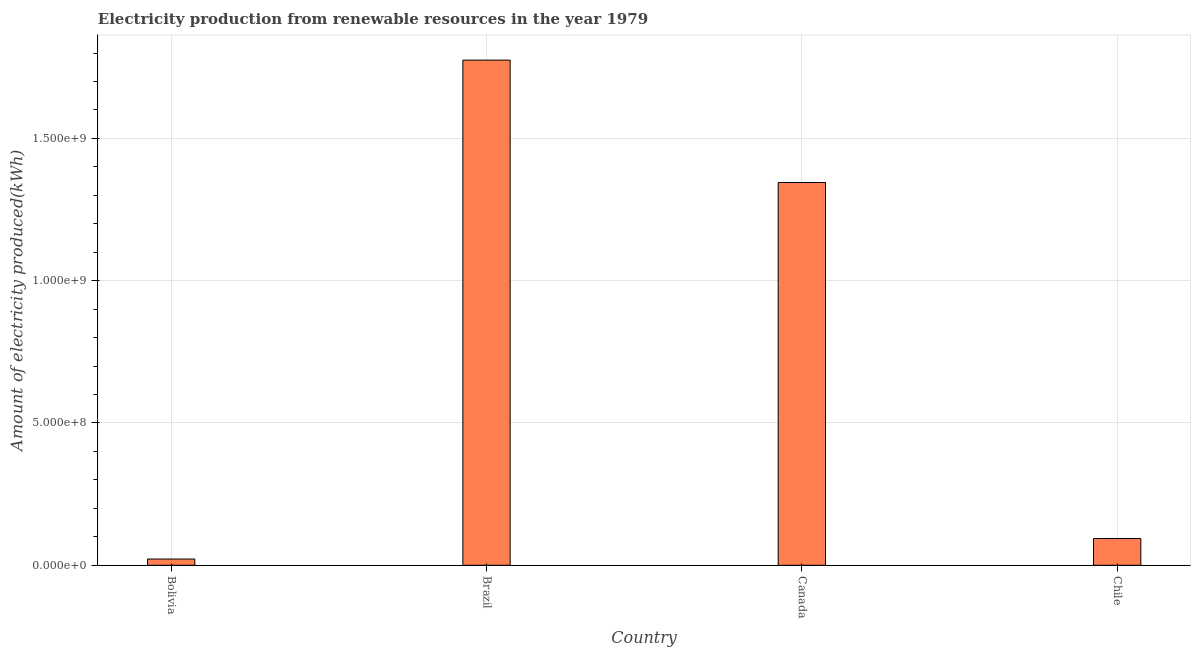What is the title of the graph?
Ensure brevity in your answer.  Electricity production from renewable resources in the year 1979. What is the label or title of the X-axis?
Offer a very short reply. Country. What is the label or title of the Y-axis?
Offer a terse response. Amount of electricity produced(kWh). What is the amount of electricity produced in Bolivia?
Offer a very short reply. 2.20e+07. Across all countries, what is the maximum amount of electricity produced?
Ensure brevity in your answer.  1.78e+09. Across all countries, what is the minimum amount of electricity produced?
Offer a terse response. 2.20e+07. In which country was the amount of electricity produced maximum?
Give a very brief answer. Brazil. What is the sum of the amount of electricity produced?
Offer a terse response. 3.24e+09. What is the difference between the amount of electricity produced in Brazil and Canada?
Provide a short and direct response. 4.30e+08. What is the average amount of electricity produced per country?
Make the answer very short. 8.09e+08. What is the median amount of electricity produced?
Give a very brief answer. 7.20e+08. In how many countries, is the amount of electricity produced greater than 1700000000 kWh?
Your answer should be compact. 1. What is the ratio of the amount of electricity produced in Bolivia to that in Chile?
Your response must be concise. 0.23. Is the difference between the amount of electricity produced in Bolivia and Canada greater than the difference between any two countries?
Provide a succinct answer. No. What is the difference between the highest and the second highest amount of electricity produced?
Your answer should be compact. 4.30e+08. Is the sum of the amount of electricity produced in Brazil and Canada greater than the maximum amount of electricity produced across all countries?
Make the answer very short. Yes. What is the difference between the highest and the lowest amount of electricity produced?
Your response must be concise. 1.75e+09. Are all the bars in the graph horizontal?
Ensure brevity in your answer.  No. What is the difference between two consecutive major ticks on the Y-axis?
Your answer should be compact. 5.00e+08. Are the values on the major ticks of Y-axis written in scientific E-notation?
Make the answer very short. Yes. What is the Amount of electricity produced(kWh) of Bolivia?
Offer a very short reply. 2.20e+07. What is the Amount of electricity produced(kWh) in Brazil?
Make the answer very short. 1.78e+09. What is the Amount of electricity produced(kWh) of Canada?
Provide a short and direct response. 1.34e+09. What is the Amount of electricity produced(kWh) in Chile?
Keep it short and to the point. 9.40e+07. What is the difference between the Amount of electricity produced(kWh) in Bolivia and Brazil?
Provide a short and direct response. -1.75e+09. What is the difference between the Amount of electricity produced(kWh) in Bolivia and Canada?
Provide a succinct answer. -1.32e+09. What is the difference between the Amount of electricity produced(kWh) in Bolivia and Chile?
Provide a succinct answer. -7.20e+07. What is the difference between the Amount of electricity produced(kWh) in Brazil and Canada?
Your answer should be very brief. 4.30e+08. What is the difference between the Amount of electricity produced(kWh) in Brazil and Chile?
Keep it short and to the point. 1.68e+09. What is the difference between the Amount of electricity produced(kWh) in Canada and Chile?
Your answer should be very brief. 1.25e+09. What is the ratio of the Amount of electricity produced(kWh) in Bolivia to that in Brazil?
Your answer should be compact. 0.01. What is the ratio of the Amount of electricity produced(kWh) in Bolivia to that in Canada?
Provide a short and direct response. 0.02. What is the ratio of the Amount of electricity produced(kWh) in Bolivia to that in Chile?
Make the answer very short. 0.23. What is the ratio of the Amount of electricity produced(kWh) in Brazil to that in Canada?
Offer a terse response. 1.32. What is the ratio of the Amount of electricity produced(kWh) in Brazil to that in Chile?
Offer a terse response. 18.88. What is the ratio of the Amount of electricity produced(kWh) in Canada to that in Chile?
Your answer should be compact. 14.31. 